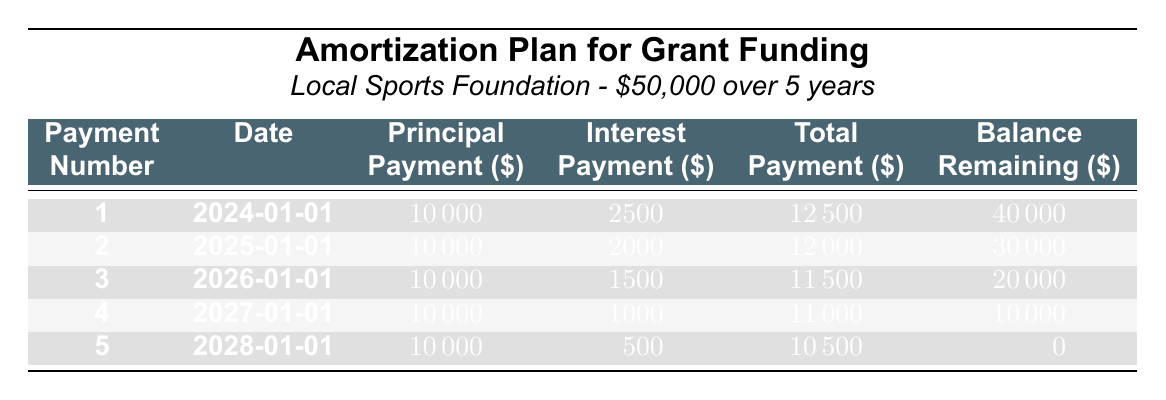What is the total grant funding amount received? The total grant funding amount is directly listed in the table under "fundingAmount," which is $50,000.
Answer: 50000 When is the first payment due? The first payment date is clearly shown in the table under the "Date" column for payment number 1, which is January 1, 2024.
Answer: 2024-01-01 What is the total payment amount for the third payment? The total payment amount for the third payment is listed in the "Total" column for payment number 3, which is $11,500.
Answer: 11500 Is the interest payment for the fifth payment lower than that for the first payment? The interest payment for the fifth payment is $500, and for the first payment, it is $2,500. Since $500 is less than $2,500, the statement is true.
Answer: Yes What is the remaining balance after the fourth payment? The remaining balance after the fourth payment is shown in the "Remaining" column for payment number 4, which is $10,000.
Answer: 10000 How much total principal is paid off after two payments? The principal payments for the first two payments are each $10,000, so the total principal after two payments is $10,000 + $10,000 = $20,000.
Answer: 20000 Is the total payment for the second year greater than the total payment for the first year? The total payment for the first year is $12,500 (first payment) and for the second year is $12,000 (second payment). Since $12,500 is greater than $12,000, the statement is false.
Answer: No What is the trend in interest payments over the years? Reviewing the "Interest" column, the payments decrease from $2,500 in the first year to $500 in the fifth year, indicating a decreasing trend in interest payments.
Answer: Decreasing trend What will be the total amount paid by the end of the grant term? To find the total amount paid by the end of the grant term, sum all total payments: $12,500 + $12,000 + $11,500 + $11,000 + $10,500 = $57,500.
Answer: 57500 